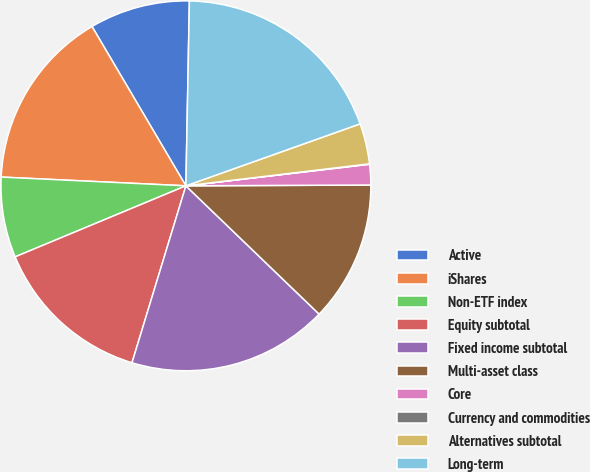Convert chart. <chart><loc_0><loc_0><loc_500><loc_500><pie_chart><fcel>Active<fcel>iShares<fcel>Non-ETF index<fcel>Equity subtotal<fcel>Fixed income subtotal<fcel>Multi-asset class<fcel>Core<fcel>Currency and commodities<fcel>Alternatives subtotal<fcel>Long-term<nl><fcel>8.78%<fcel>15.77%<fcel>7.03%<fcel>14.02%<fcel>17.51%<fcel>12.27%<fcel>1.79%<fcel>0.04%<fcel>3.54%<fcel>19.26%<nl></chart> 